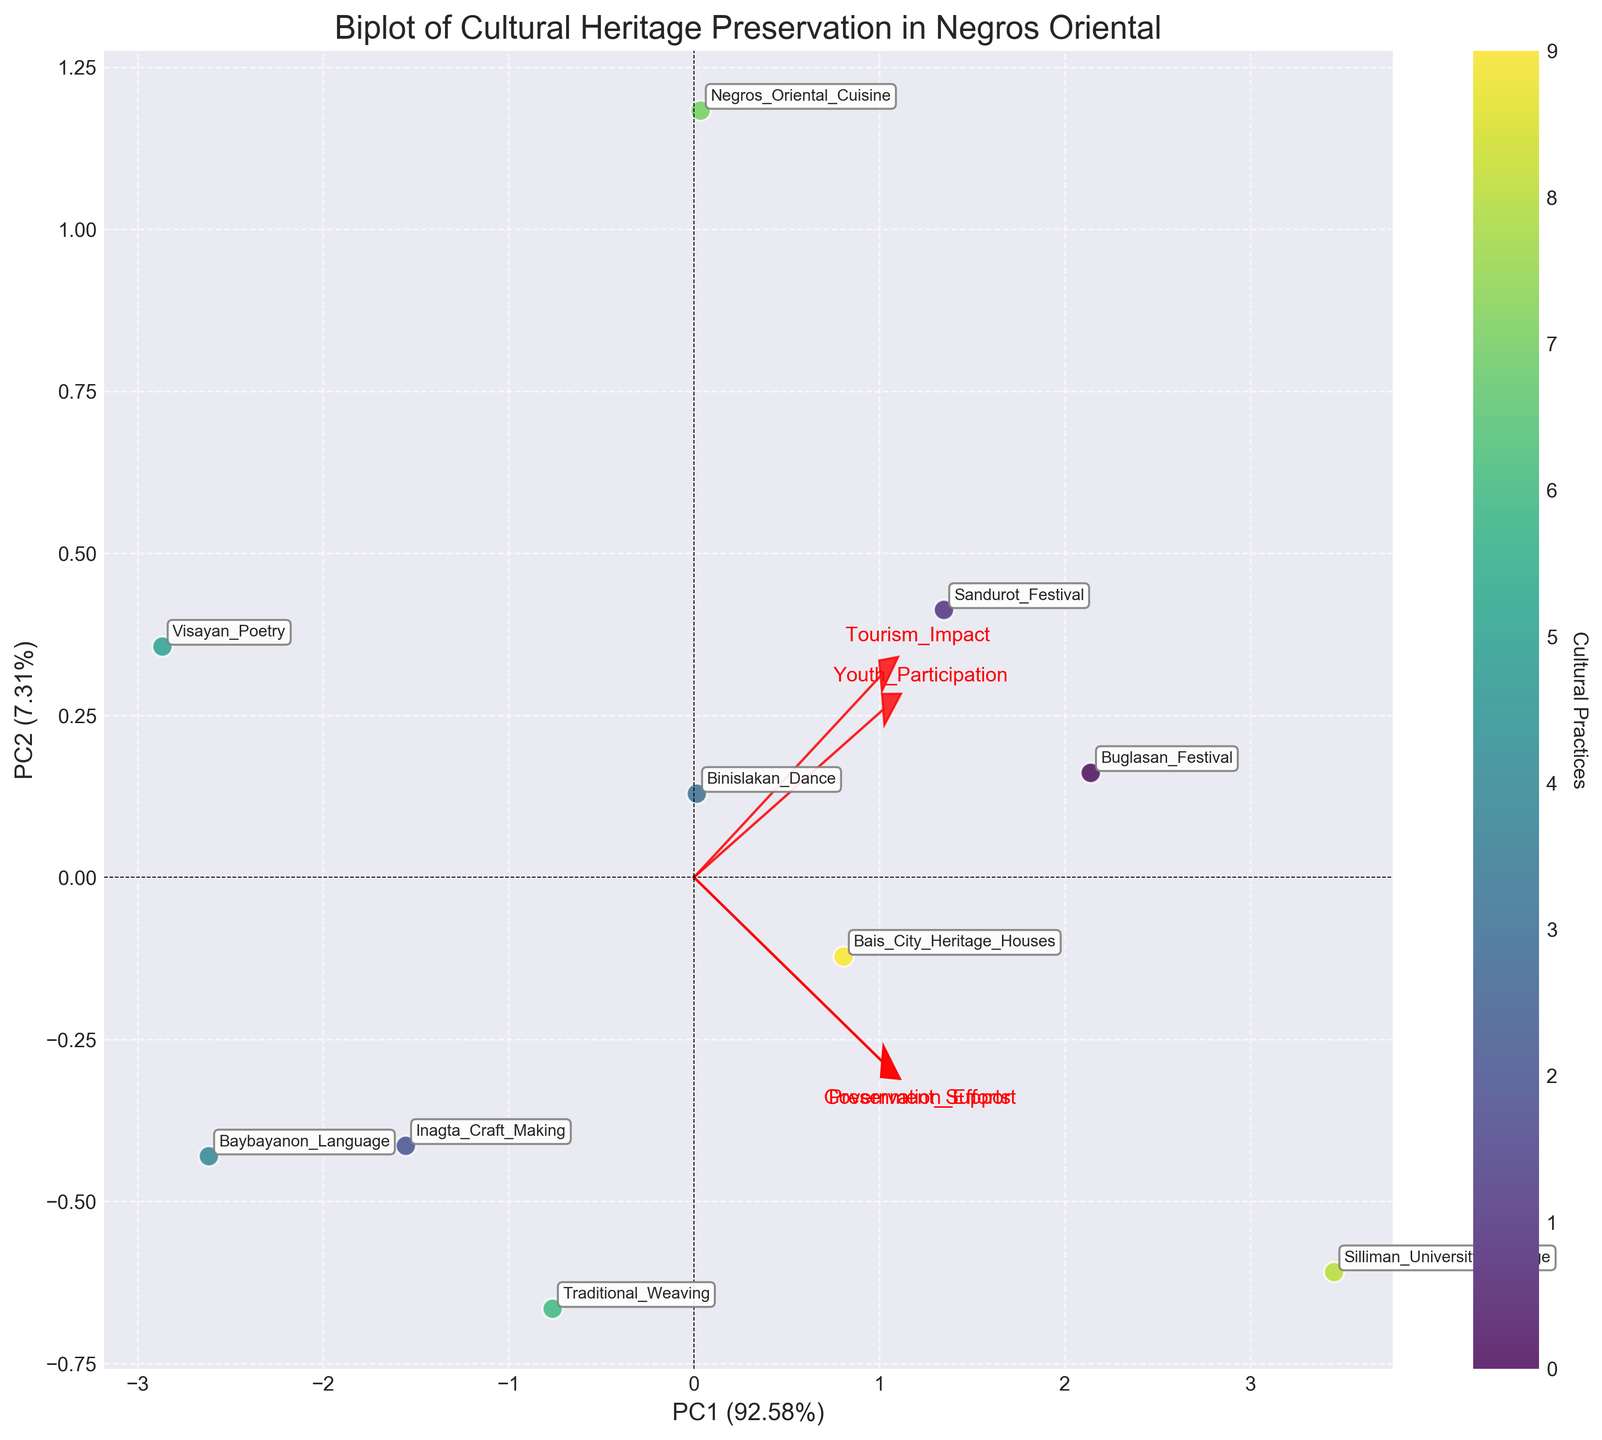what is the title of the figure? The title of the figure is often displayed at the top of the plot. By referring to the top part of the plot, we can read the title.
Answer: Biplot of Cultural Heritage Preservation in Negros Oriental How many cultural practices are represented in the plot? Each cultural practice is represented by a scatter point in the plot. By counting these points, we can determine the number of cultural practices.
Answer: 10 Which cultural practice has the highest youth participation? The cultural practice with the highest youth participation will be positioned highest on the respective arrow representing youth participation in the biplot.
Answer: Silliman University Heritage Which vector (loading) represents government support? Vectors are labeled by their respective attributes. By identifying the label 'Government Support' on the plot, we can locate which vector represents it.
Answer: The vector pointing in a specific direction labeled 'Government Support' Which two cultural practices are closest to each other in the PCA space? By observing the scatter points, we can find the two points that are closest to each other in terms of Euclidean distance (straight-line distance).
Answer: Sandurot Festival and Traditional Weaving What does the direction of the arrow for tourism impact indicate? The direction of an arrow in a biplot indicates the positive direction of that variable. The further a point lies in the direction of this arrow, the higher it scores on that attribute.
Answer: Positive trend associated with tourism impact How are Baybayanon Language and Visayan Poetry positioned relative to each other in the plot? We compare the relative positions of the two scatter points labeled 'Baybayanon Language' and 'Visayan Poetry' in the plot.
Answer: Baybayanon Language is to the left and slightly below Visayan Poetry Which items have relatively high scores on both principal components (PC1 and PC2)? Items located in the upper right quadrant of the biplot have high scores on both principal components.
Answer: Buglasan Festival and Silliman University Heritage What characteristic does the arrow for preservation efforts represent? Arrows in a biplot represent different variables. The arrow labeled 'Preservation Efforts' shows the direction in which this variable grows.
Answer: Represents direction and strength of preservation efforts Are there more items in the positive space of PC1 or PC2? By inspecting the plot, count whether more points lie to the right (positive PC1) or above (positive PC2) the origin.
Answer: Positive space of PC1 